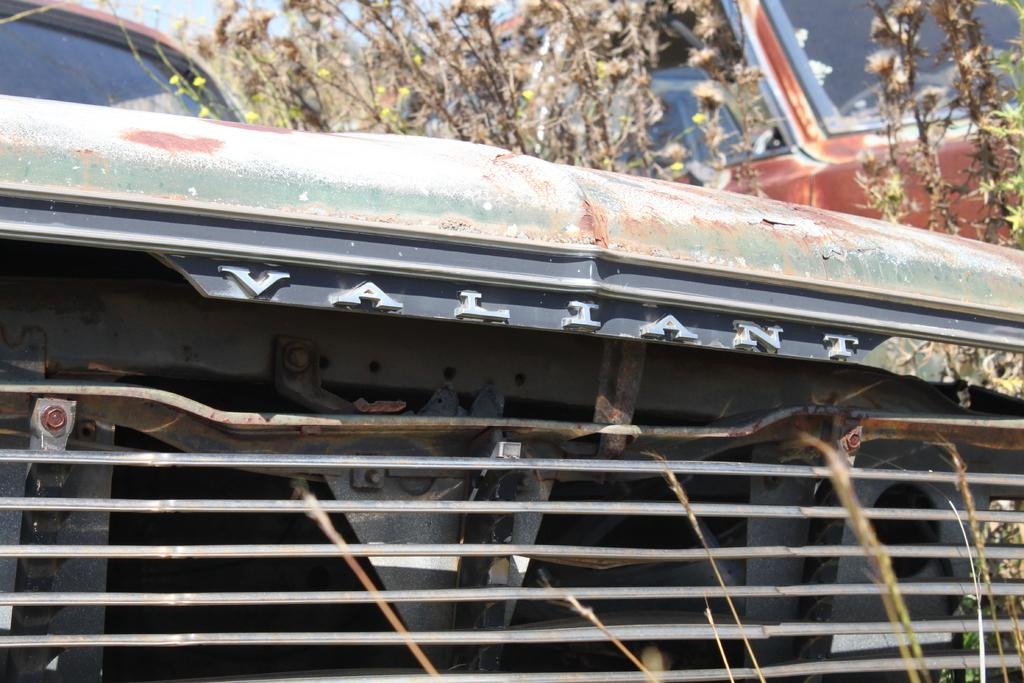What is the main subject of the image? The main subject of the image is a car. Can you describe any specific details about the car? Unfortunately, the provided facts do not mention any specific details about the car. What else can be seen in the image besides the car? There are plants visible in the image. What type of suggestion can be seen written on the glove in the image? There is no glove present in the image, so it is not possible to answer that question. 